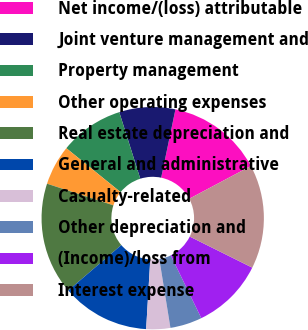Convert chart. <chart><loc_0><loc_0><loc_500><loc_500><pie_chart><fcel>Net income/(loss) attributable<fcel>Joint venture management and<fcel>Property management<fcel>Other operating expenses<fcel>Real estate depreciation and<fcel>General and administrative<fcel>Casualty-related<fcel>Other depreciation and<fcel>(Income)/loss from<fcel>Interest expense<nl><fcel>13.95%<fcel>8.14%<fcel>9.3%<fcel>5.82%<fcel>16.28%<fcel>12.79%<fcel>3.49%<fcel>4.65%<fcel>10.46%<fcel>15.11%<nl></chart> 